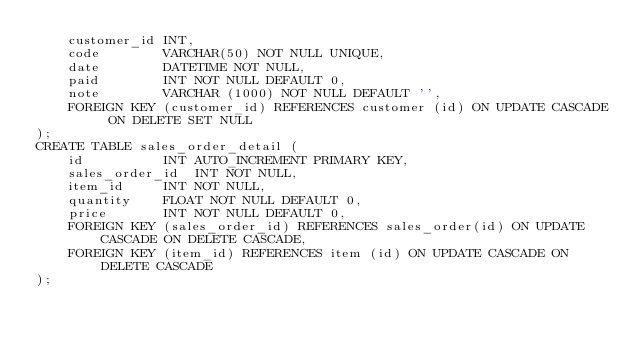Convert code to text. <code><loc_0><loc_0><loc_500><loc_500><_SQL_>	customer_id	INT,
	code		VARCHAR(50) NOT NULL UNIQUE,
	date		DATETIME NOT NULL,
	paid		INT NOT NULL DEFAULT 0,
	note		VARCHAR (1000) NOT NULL DEFAULT '',
	FOREIGN KEY (customer_id) REFERENCES customer (id) ON UPDATE CASCADE ON DELETE SET NULL
);
CREATE TABLE sales_order_detail (
	id			INT AUTO_INCREMENT PRIMARY KEY,
	sales_order_id	INT NOT NULL,
	item_id		INT NOT NULL,
	quantity	FLOAT NOT NULL DEFAULT 0,
	price		INT NOT NULL DEFAULT 0,
	FOREIGN KEY (sales_order_id) REFERENCES sales_order(id) ON UPDATE CASCADE ON DELETE CASCADE,
	FOREIGN KEY (item_id) REFERENCES item (id) ON UPDATE CASCADE ON DELETE CASCADE
);</code> 